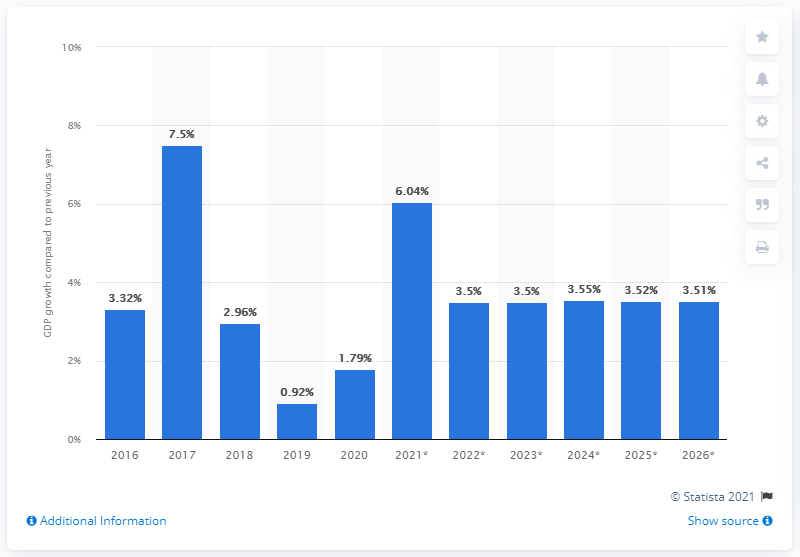Point out several critical features in this image. In 2020, the real GDP of Turkey grew by 1.79%. 